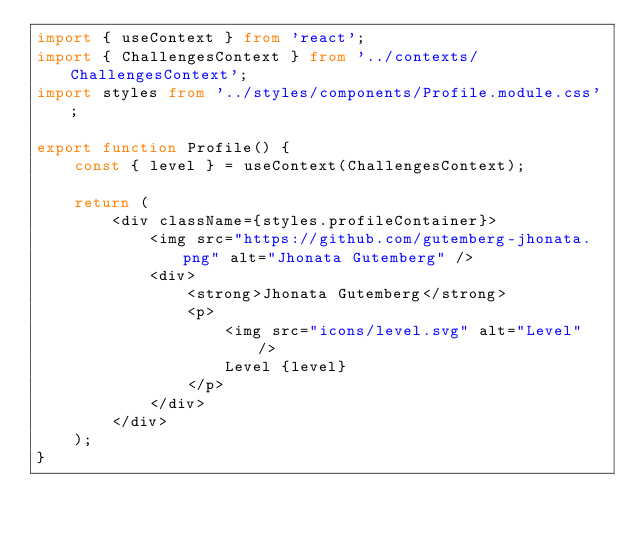Convert code to text. <code><loc_0><loc_0><loc_500><loc_500><_TypeScript_>import { useContext } from 'react';
import { ChallengesContext } from '../contexts/ChallengesContext';
import styles from '../styles/components/Profile.module.css';

export function Profile() {
    const { level } = useContext(ChallengesContext);

    return (
        <div className={styles.profileContainer}>
            <img src="https://github.com/gutemberg-jhonata.png" alt="Jhonata Gutemberg" />
            <div>
                <strong>Jhonata Gutemberg</strong>
                <p>
                    <img src="icons/level.svg" alt="Level" />
                    Level {level}
                </p>                
            </div>
        </div>
    );
}</code> 